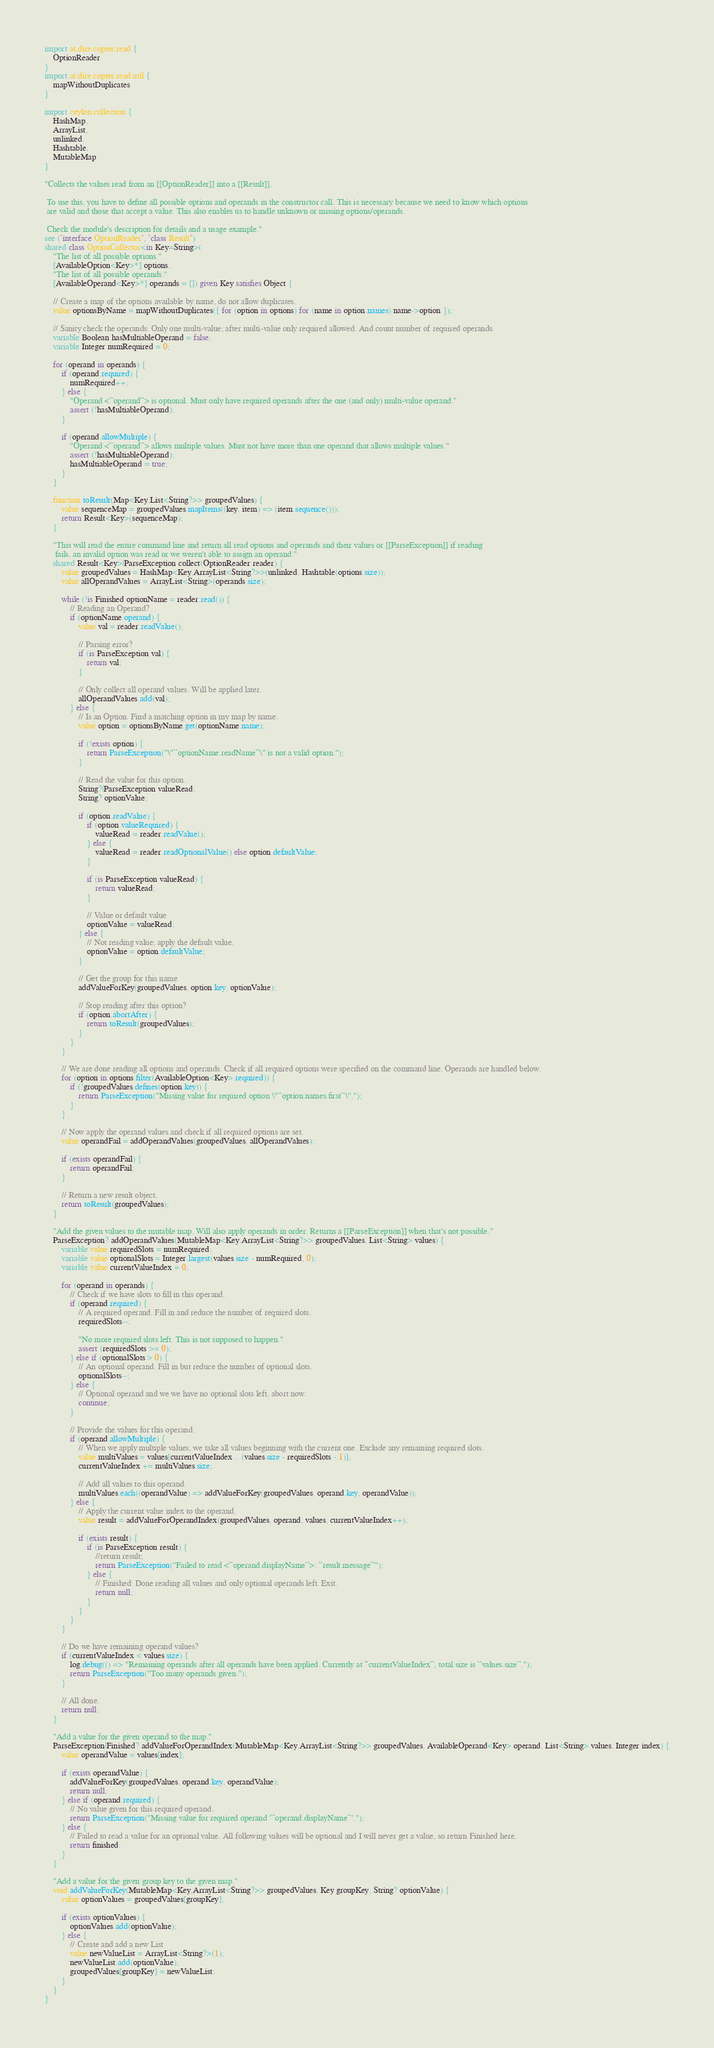<code> <loc_0><loc_0><loc_500><loc_500><_Ceylon_>import at.dire.copter.read {
	OptionReader
}
import at.dire.copter.read.util {
	mapWithoutDuplicates
}

import ceylon.collection {
	HashMap,
	ArrayList,
	unlinked,
	Hashtable,
	MutableMap
}

"Collects the values read from an [[OptionReader]] into a [[Result]].

 To use this, you have to define all possible options and operands in the constructor call. This is necessary because we need to know which options
 are valid and those that accept a value. This also enables us to handle unknown or missing options/operands.

 Check the module's description for details and a usage example."
see (`interface OptionReader`, `class Result`)
shared class OptionCollector<in Key=String>(
	"The list of all possible options."
	[AvailableOption<Key>*] options,
	"The list of all possible operands."
	[AvailableOperand<Key>*] operands = []) given Key satisfies Object {

	// Create a map of the options available by name, do not allow duplicates.
	value optionsByName = mapWithoutDuplicates({ for (option in options) for (name in option.names) name->option });

	// Sanity check the operands: Only one multi-value; after multi-value only required allowed. And count number of required operands.
	variable Boolean hasMultiableOperand = false;
	variable Integer numRequired = 0;

	for (operand in operands) {
		if (operand.required) {
			numRequired++;
		} else {
			"Operand <``operand``> is optional. Must only have required operands after the one (and only) multi-value operand."
			assert (!hasMultiableOperand);
		}

		if (operand.allowMultiple) {
			"Operand <``operand``> allows multiple values. Must not have more than one operand that allows multiple values."
			assert (!hasMultiableOperand);
			hasMultiableOperand = true;
		}
	}

	function toResult(Map<Key,List<String?>> groupedValues) {
		value sequenceMap = groupedValues.mapItems((key, item) => (item.sequence()));
		return Result<Key>(sequenceMap);
	}

	"This will read the entire command line and return all read options and operands and their values or [[ParseException]] if reading
	 fails, an invalid option was read or we weren't able to assign an operand."
	shared Result<Key>|ParseException collect(OptionReader reader) {
		value groupedValues = HashMap<Key,ArrayList<String?>>(unlinked, Hashtable(options.size));
		value allOperandValues = ArrayList<String>(operands.size);

		while (!is Finished optionName = reader.read()) {
			// Reading an Operand?
			if (optionName.operand) {
				value val = reader.readValue();

				// Parsing error?
				if (is ParseException val) {
					return val;
				}

				// Only collect all operand values. Will be applied later.
				allOperandValues.add(val);
			} else {
				// Is an Option. Find a matching option in my map by name.
				value option = optionsByName.get(optionName.name);

				if (!exists option) {
					return ParseException("\"``optionName.readName``\" is not a valid option.");
				}

				// Read the value for this option.
				String?|ParseException valueRead;
				String? optionValue;

				if (option.readValue) {
					if (option.valueRequired) {
						valueRead = reader.readValue();
					} else {
						valueRead = reader.readOptionalValue() else option.defaultValue;
					}

					if (is ParseException valueRead) {
						return valueRead;
					}

					// Value or default value
					optionValue = valueRead;
				} else {
					// Not reading value; apply the default value.
					optionValue = option.defaultValue;
				}

				// Get the group for this name
				addValueForKey(groupedValues, option.key, optionValue);

				// Stop reading after this option?
				if (option.abortAfter) {
					return toResult(groupedValues);
				}
			}
		}

		// We are done reading all options and operands. Check if all required options were specified on the command line. Operands are handled below.
		for (option in options.filter(AvailableOption<Key>.required)) {
			if (!groupedValues.defines(option.key)) {
				return ParseException("Missing value for required option \"``option.names.first``\".");
			}
		}

		// Now apply the operand values and check if all required options are set.
		value operandFail = addOperandValues(groupedValues, allOperandValues);

		if (exists operandFail) {
			return operandFail;
		}

		// Return a new result object.
		return toResult(groupedValues);
	}

	"Add the given values to the mutable map. Will also apply operands in order. Returns a [[ParseException]] when that's not possible."
	ParseException? addOperandValues(MutableMap<Key,ArrayList<String?>> groupedValues, List<String> values) {
		variable value requiredSlots = numRequired;
		variable value optionalSlots = Integer.largest(values.size - numRequired, 0);
		variable value currentValueIndex = 0;

		for (operand in operands) {
			// Check if we have slots to fill in this operand.
			if (operand.required) {
				// A required operand. Fill in and reduce the number of required slots.
				requiredSlots--;

				"No more required slots left. This is not supposed to happen."
				assert (requiredSlots >= 0);
			} else if (optionalSlots > 0) {
				// An optional operand. Fill in but reduce the number of optional slots.
				optionalSlots--;
			} else {
				// Optional operand and we we have no optional slots left, abort now.
				continue;
			}

			// Provide the values for this operand.
			if (operand.allowMultiple) {
				// When we apply multiple values, we take all values beginning with the current one. Exclude any remaining required slots.
				value multiValues = values[currentValueIndex .. (values.size - requiredSlots - 1)];
				currentValueIndex += multiValues.size;

				// Add all values to this operand.
				multiValues.each((operandValue) => addValueForKey(groupedValues, operand.key, operandValue));
			} else {
				// Apply the current value index to the operand.
				value result = addValueForOperandIndex(groupedValues, operand, values, currentValueIndex++);

				if (exists result) {
					if (is ParseException result) {
						//return result;
						return ParseException("Failed to read <``operand.displayName``>: ``result.message``");
					} else {
						// Finished: Done reading all values and only optional operands left. Exit.
						return null;
					}
				}
			}
		}

		// Do we have remaining operand values?
		if (currentValueIndex < values.size) {
			log.debug(() => "Remaining operands after all operands have been applied. Currently at ``currentValueIndex``, total size is ``values.size``.");
			return ParseException("Too many operands given.");
		}

		// All done.
		return null;
	}

	"Add a value for the given operand to the map."
	ParseException|Finished? addValueForOperandIndex(MutableMap<Key,ArrayList<String?>> groupedValues, AvailableOperand<Key> operand, List<String> values, Integer index) {
		value operandValue = values[index];

		if (exists operandValue) {
			addValueForKey(groupedValues, operand.key, operandValue);
			return null;
		} else if (operand.required) {
			// No value given for this required operand.
			return ParseException("Missing value for required operand '``operand.displayName``'.");
		} else {
			// Failed to read a value for an optional value. All following values will be optional and I will never get a value, so return Finished here.
			return finished;
		}
	}

	"Add a value for the given group key to the given map."
	void addValueForKey(MutableMap<Key,ArrayList<String?>> groupedValues, Key groupKey, String? optionValue) {
		value optionValues = groupedValues[groupKey];

		if (exists optionValues) {
			optionValues.add(optionValue);
		} else {
			// Create and add a new List
			value newValueList = ArrayList<String?>(1);
			newValueList.add(optionValue);
			groupedValues[groupKey] = newValueList;
		}
	}
}
</code> 